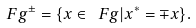<formula> <loc_0><loc_0><loc_500><loc_500>\ F g ^ { \pm } = \{ x \in \ F g | x ^ { * } = \mp x \} .</formula> 